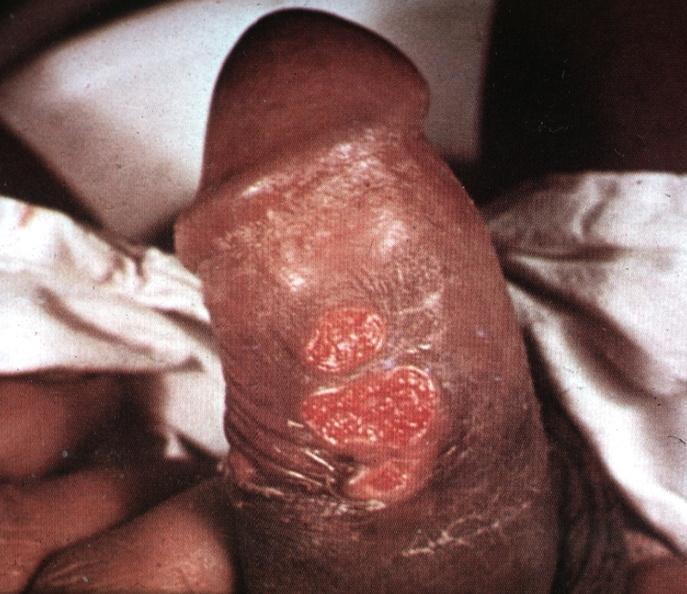what is present?
Answer the question using a single word or phrase. Chancre 